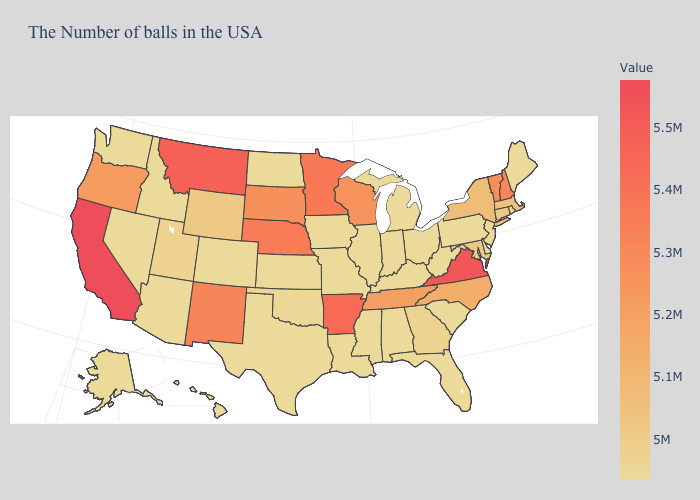Among the states that border Wisconsin , does Minnesota have the highest value?
Be succinct. Yes. Does Vermont have a higher value than Missouri?
Quick response, please. Yes. Among the states that border Nebraska , does South Dakota have the highest value?
Write a very short answer. Yes. Which states have the highest value in the USA?
Be succinct. California. Is the legend a continuous bar?
Give a very brief answer. Yes. Does the map have missing data?
Keep it brief. No. Among the states that border South Dakota , which have the highest value?
Keep it brief. Montana. Which states hav the highest value in the Northeast?
Give a very brief answer. New Hampshire. Does New Hampshire have the highest value in the Northeast?
Give a very brief answer. Yes. 